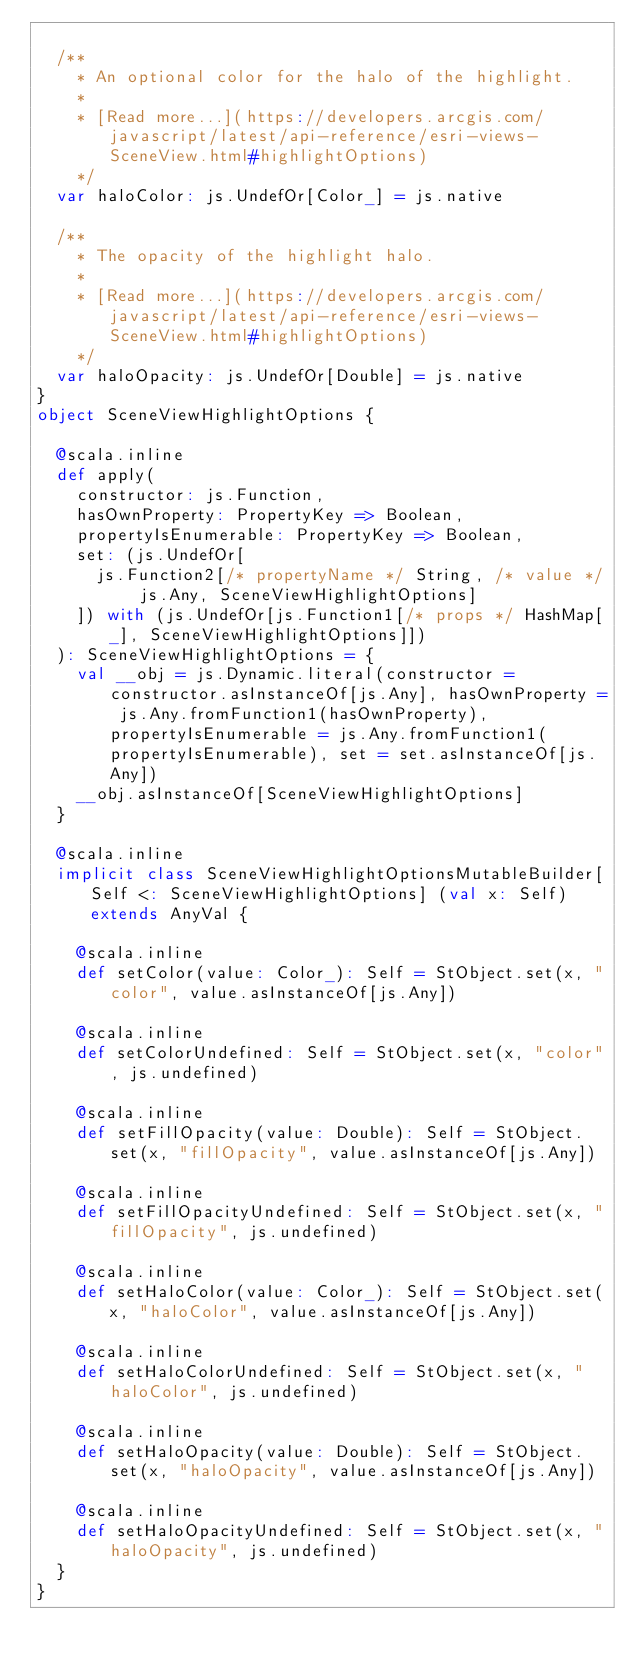<code> <loc_0><loc_0><loc_500><loc_500><_Scala_>  
  /**
    * An optional color for the halo of the highlight.
    *
    * [Read more...](https://developers.arcgis.com/javascript/latest/api-reference/esri-views-SceneView.html#highlightOptions)
    */
  var haloColor: js.UndefOr[Color_] = js.native
  
  /**
    * The opacity of the highlight halo.
    *
    * [Read more...](https://developers.arcgis.com/javascript/latest/api-reference/esri-views-SceneView.html#highlightOptions)
    */
  var haloOpacity: js.UndefOr[Double] = js.native
}
object SceneViewHighlightOptions {
  
  @scala.inline
  def apply(
    constructor: js.Function,
    hasOwnProperty: PropertyKey => Boolean,
    propertyIsEnumerable: PropertyKey => Boolean,
    set: (js.UndefOr[
      js.Function2[/* propertyName */ String, /* value */ js.Any, SceneViewHighlightOptions]
    ]) with (js.UndefOr[js.Function1[/* props */ HashMap[_], SceneViewHighlightOptions]])
  ): SceneViewHighlightOptions = {
    val __obj = js.Dynamic.literal(constructor = constructor.asInstanceOf[js.Any], hasOwnProperty = js.Any.fromFunction1(hasOwnProperty), propertyIsEnumerable = js.Any.fromFunction1(propertyIsEnumerable), set = set.asInstanceOf[js.Any])
    __obj.asInstanceOf[SceneViewHighlightOptions]
  }
  
  @scala.inline
  implicit class SceneViewHighlightOptionsMutableBuilder[Self <: SceneViewHighlightOptions] (val x: Self) extends AnyVal {
    
    @scala.inline
    def setColor(value: Color_): Self = StObject.set(x, "color", value.asInstanceOf[js.Any])
    
    @scala.inline
    def setColorUndefined: Self = StObject.set(x, "color", js.undefined)
    
    @scala.inline
    def setFillOpacity(value: Double): Self = StObject.set(x, "fillOpacity", value.asInstanceOf[js.Any])
    
    @scala.inline
    def setFillOpacityUndefined: Self = StObject.set(x, "fillOpacity", js.undefined)
    
    @scala.inline
    def setHaloColor(value: Color_): Self = StObject.set(x, "haloColor", value.asInstanceOf[js.Any])
    
    @scala.inline
    def setHaloColorUndefined: Self = StObject.set(x, "haloColor", js.undefined)
    
    @scala.inline
    def setHaloOpacity(value: Double): Self = StObject.set(x, "haloOpacity", value.asInstanceOf[js.Any])
    
    @scala.inline
    def setHaloOpacityUndefined: Self = StObject.set(x, "haloOpacity", js.undefined)
  }
}
</code> 